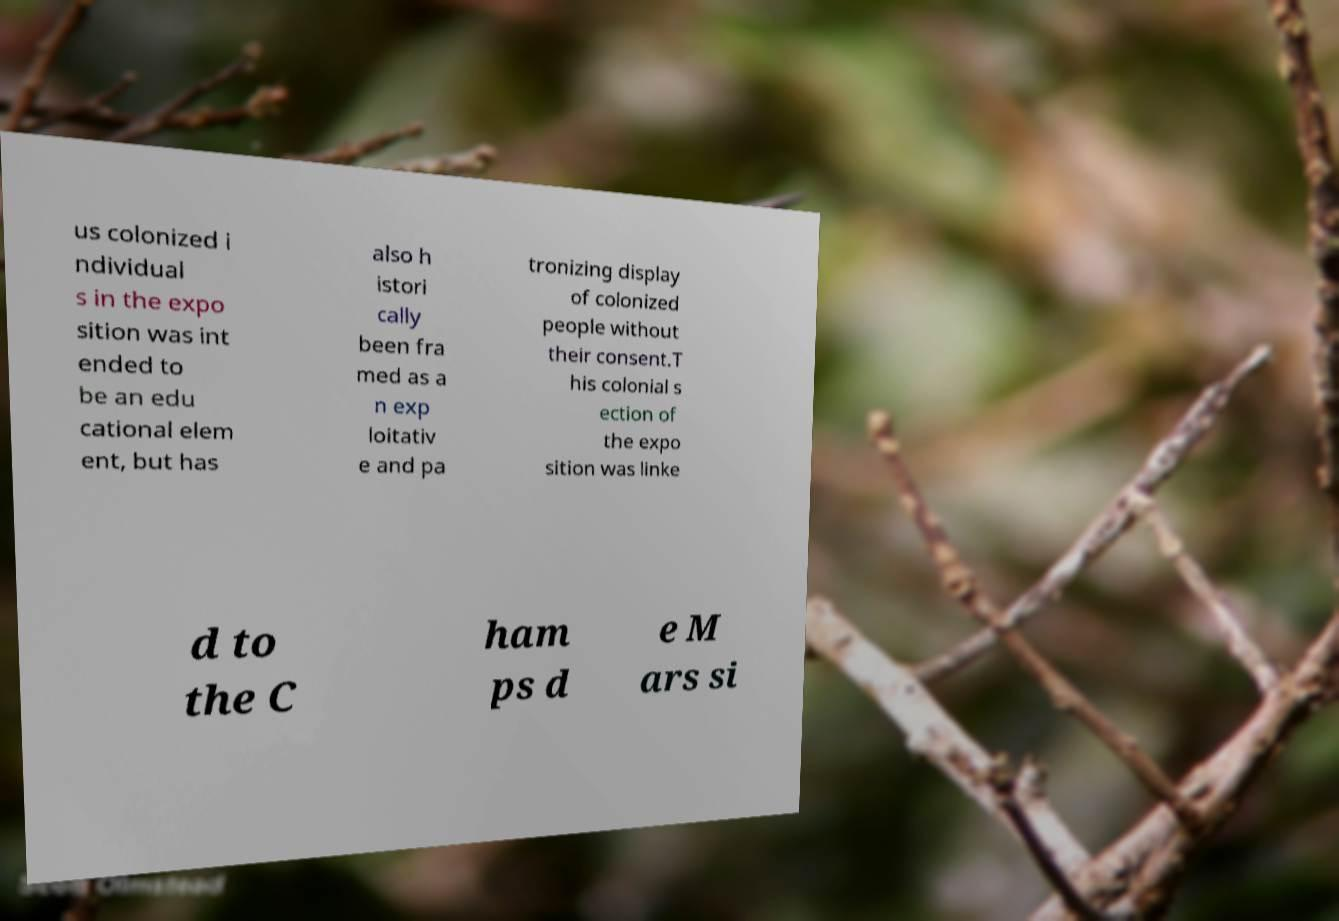Could you assist in decoding the text presented in this image and type it out clearly? us colonized i ndividual s in the expo sition was int ended to be an edu cational elem ent, but has also h istori cally been fra med as a n exp loitativ e and pa tronizing display of colonized people without their consent.T his colonial s ection of the expo sition was linke d to the C ham ps d e M ars si 